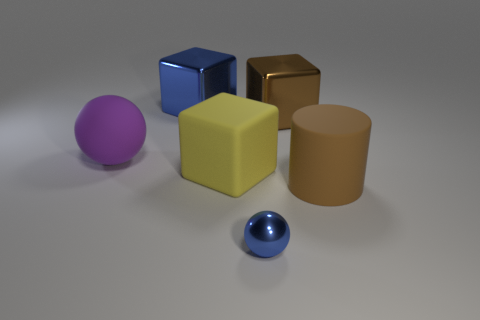Does the cylinder have the same material as the brown block?
Provide a succinct answer. No. Is there any other thing that is the same shape as the tiny object?
Your response must be concise. Yes. What is the large block that is in front of the large matte object that is on the left side of the big blue metallic cube made of?
Keep it short and to the point. Rubber. How big is the shiny cube to the left of the small blue metal thing?
Your answer should be very brief. Large. There is a metal object that is both left of the big brown metallic thing and behind the large rubber sphere; what color is it?
Provide a succinct answer. Blue. There is a brown rubber thing right of the yellow thing; does it have the same size as the blue ball?
Your answer should be very brief. No. Is there a shiny thing that is behind the brown metal cube behind the purple ball?
Provide a succinct answer. Yes. What material is the big purple object?
Ensure brevity in your answer.  Rubber. Are there any brown metal objects in front of the small blue shiny object?
Your answer should be compact. No. What is the size of the blue metallic object that is the same shape as the yellow matte object?
Your response must be concise. Large. 